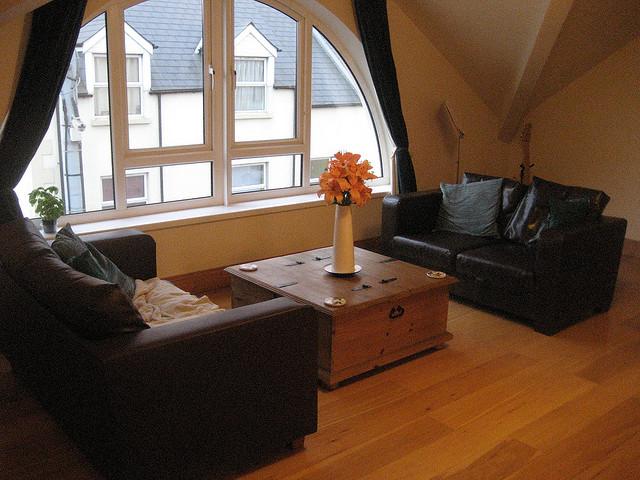Is this room upstairs?
Quick response, please. Yes. What shape is the window?
Short answer required. Half circle. What color are the couches?
Write a very short answer. Black. 